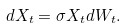<formula> <loc_0><loc_0><loc_500><loc_500>d X _ { t } = \sigma X _ { t } d W _ { t } .</formula> 